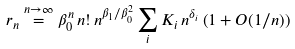Convert formula to latex. <formula><loc_0><loc_0><loc_500><loc_500>r _ { n } \stackrel { n \to \infty } { = } \beta _ { 0 } ^ { n } \, n ! \, n ^ { \beta _ { 1 } / \beta _ { 0 } ^ { 2 } } \sum _ { i } K _ { i } \, n ^ { \delta _ { i } } \left ( 1 + O ( 1 / n ) \right )</formula> 